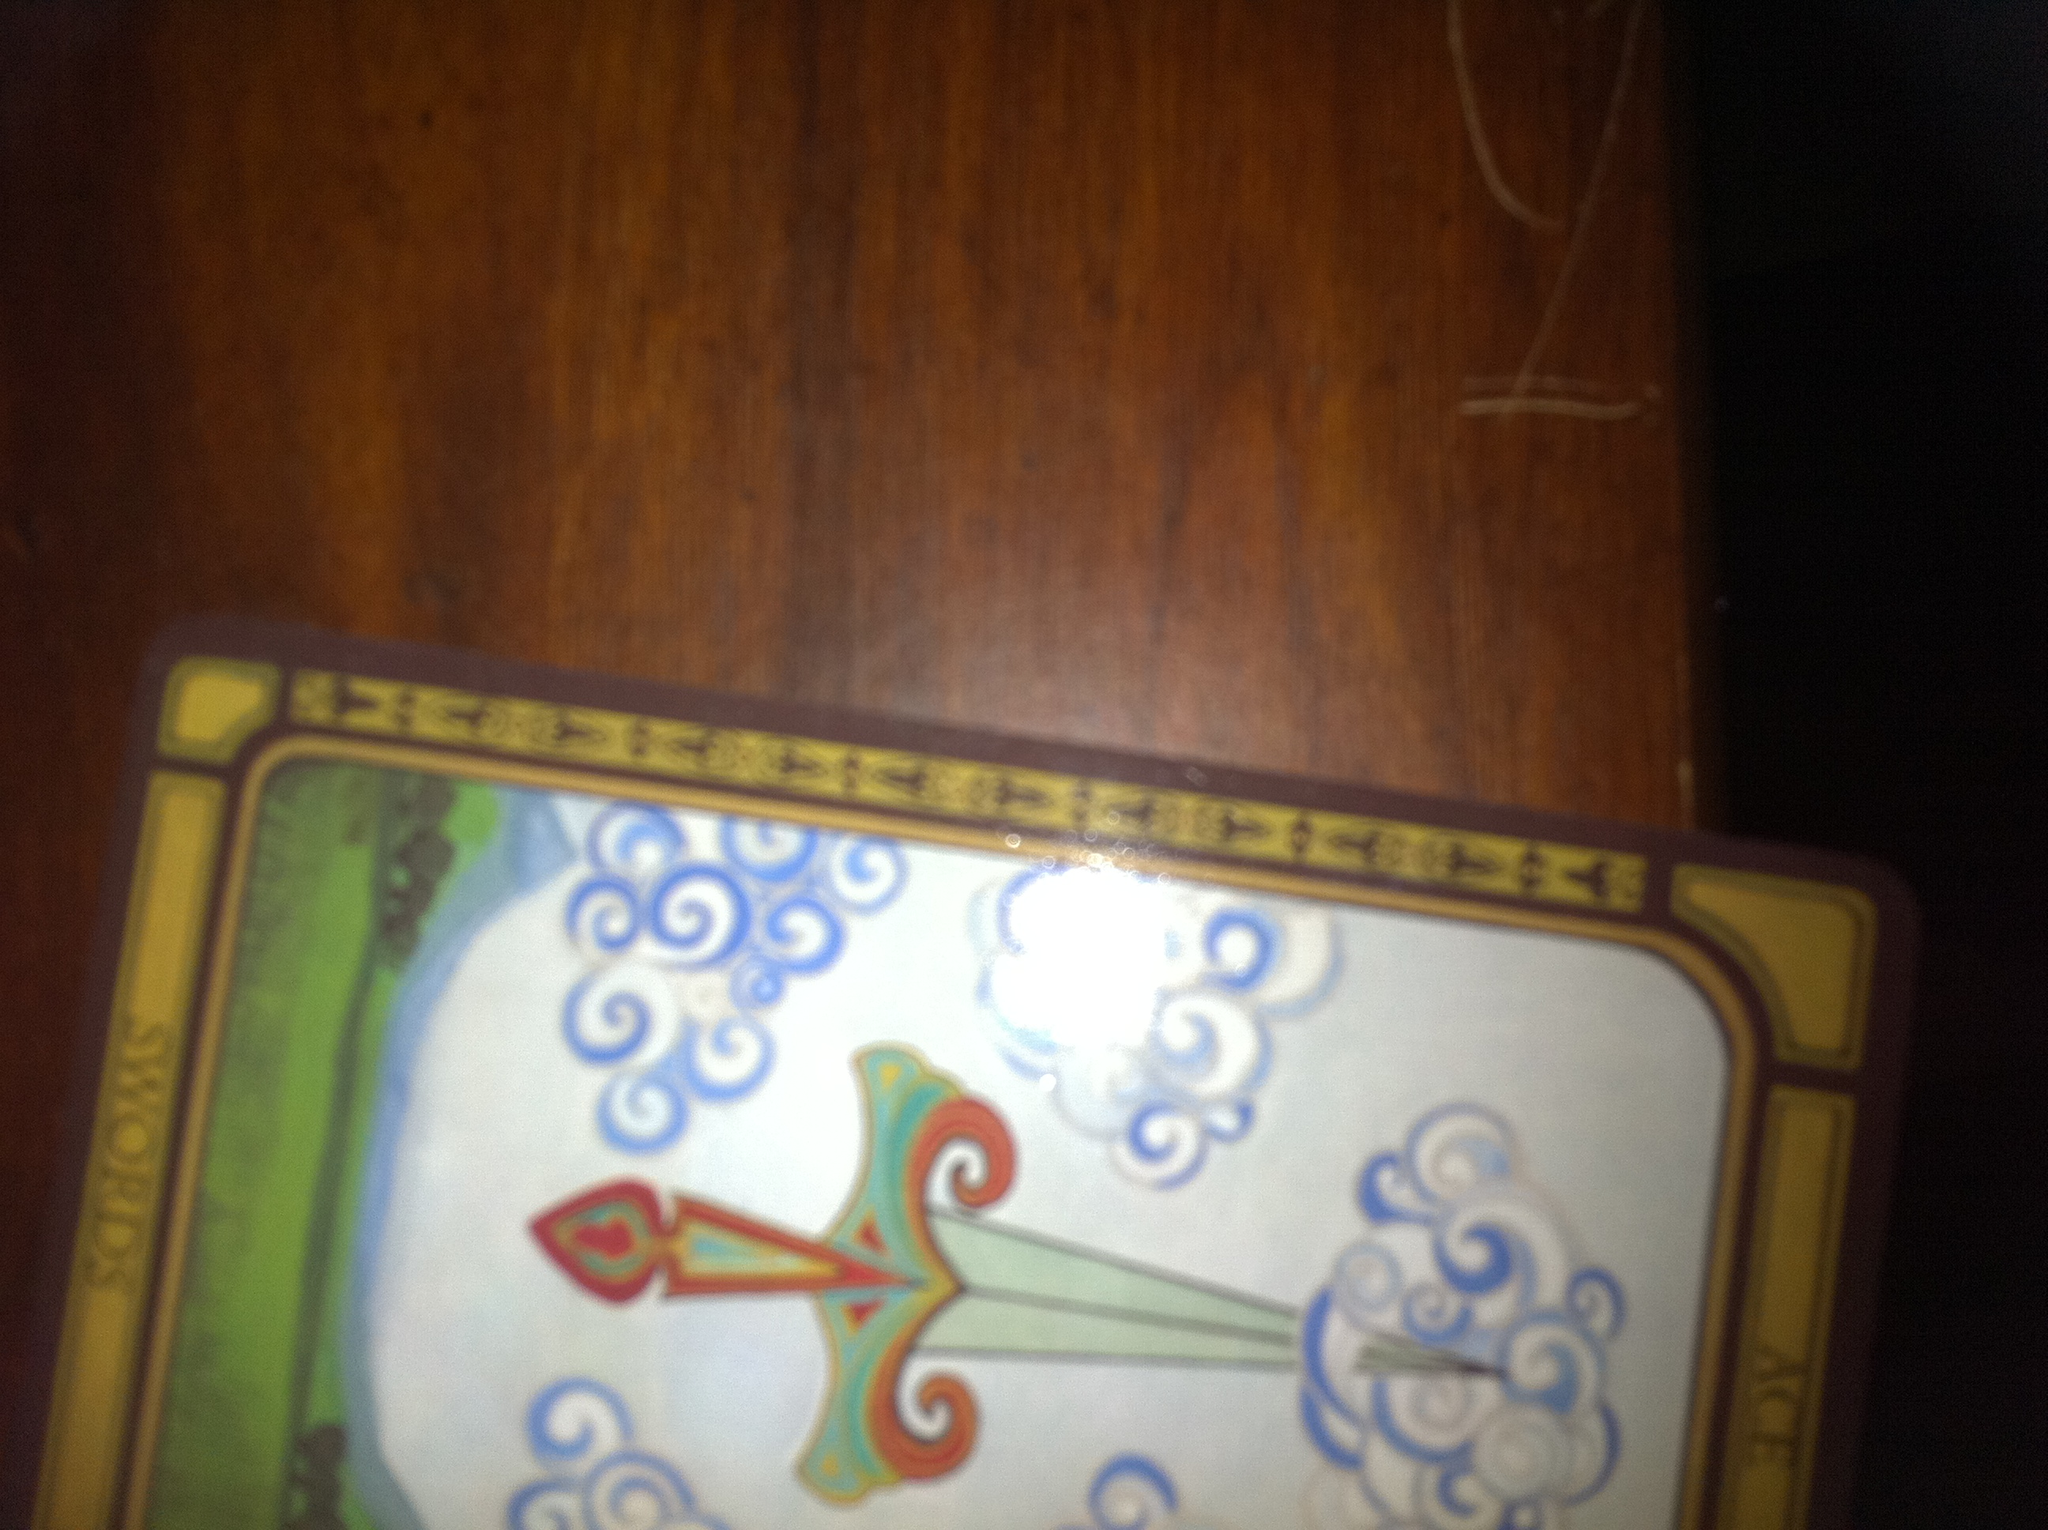How might an artist have been inspired to create this card? An artist might have been inspired by themes of clarity, intellect, and new beginnings. The design of a sword cutting through clouds could have been a powerful visual representation of these themes. The artist likely aimed to evoke a sense of mental clarity and the strength of the mind through the detailed and symbolic imagery used on the card. 